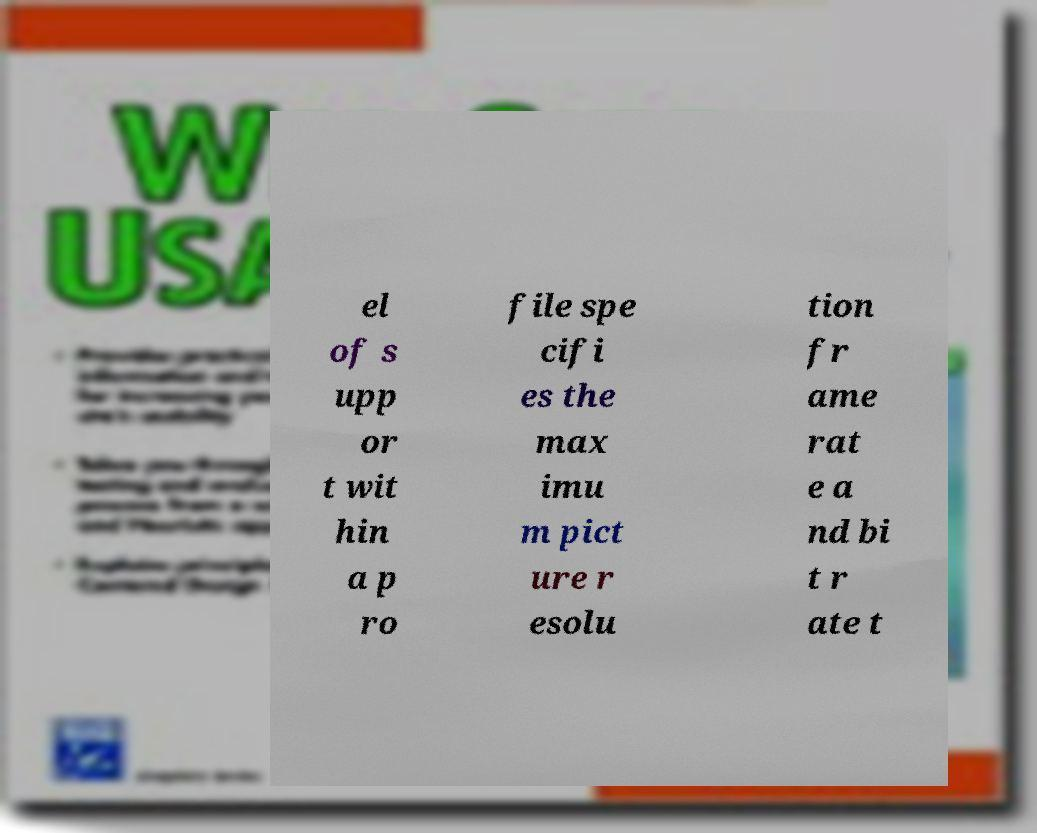For documentation purposes, I need the text within this image transcribed. Could you provide that? el of s upp or t wit hin a p ro file spe cifi es the max imu m pict ure r esolu tion fr ame rat e a nd bi t r ate t 